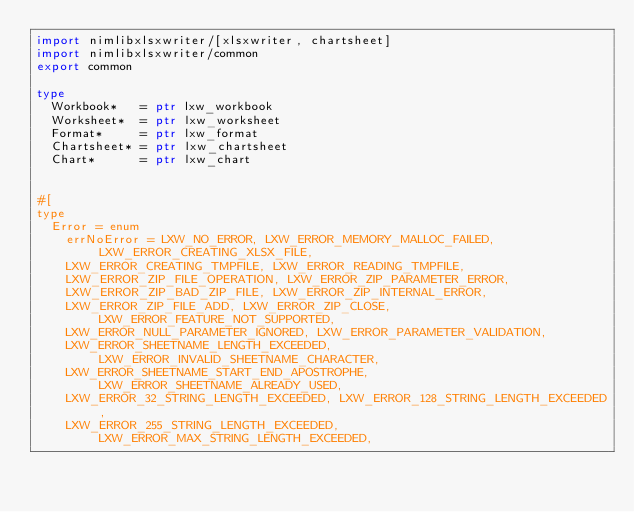Convert code to text. <code><loc_0><loc_0><loc_500><loc_500><_Nim_>import nimlibxlsxwriter/[xlsxwriter, chartsheet]
import nimlibxlsxwriter/common
export common

type
  Workbook*   = ptr lxw_workbook
  Worksheet*  = ptr lxw_worksheet
  Format*     = ptr lxw_format  
  Chartsheet* = ptr lxw_chartsheet 
  Chart*      = ptr lxw_chart 


#[
type
  Error = enum
    errNoError = LXW_NO_ERROR, LXW_ERROR_MEMORY_MALLOC_FAILED, LXW_ERROR_CREATING_XLSX_FILE,
    LXW_ERROR_CREATING_TMPFILE, LXW_ERROR_READING_TMPFILE,
    LXW_ERROR_ZIP_FILE_OPERATION, LXW_ERROR_ZIP_PARAMETER_ERROR,
    LXW_ERROR_ZIP_BAD_ZIP_FILE, LXW_ERROR_ZIP_INTERNAL_ERROR,
    LXW_ERROR_ZIP_FILE_ADD, LXW_ERROR_ZIP_CLOSE, LXW_ERROR_FEATURE_NOT_SUPPORTED,
    LXW_ERROR_NULL_PARAMETER_IGNORED, LXW_ERROR_PARAMETER_VALIDATION,
    LXW_ERROR_SHEETNAME_LENGTH_EXCEEDED, LXW_ERROR_INVALID_SHEETNAME_CHARACTER,
    LXW_ERROR_SHEETNAME_START_END_APOSTROPHE, LXW_ERROR_SHEETNAME_ALREADY_USED,
    LXW_ERROR_32_STRING_LENGTH_EXCEEDED, LXW_ERROR_128_STRING_LENGTH_EXCEEDED,
    LXW_ERROR_255_STRING_LENGTH_EXCEEDED, LXW_ERROR_MAX_STRING_LENGTH_EXCEEDED,</code> 